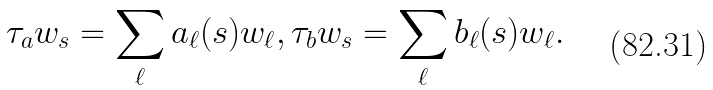<formula> <loc_0><loc_0><loc_500><loc_500>\tau _ { a } w _ { s } = \sum _ { \ell } a _ { \ell } ( s ) w _ { \ell } , \tau _ { b } w _ { s } = \sum _ { \ell } b _ { \ell } ( s ) w _ { \ell } .</formula> 